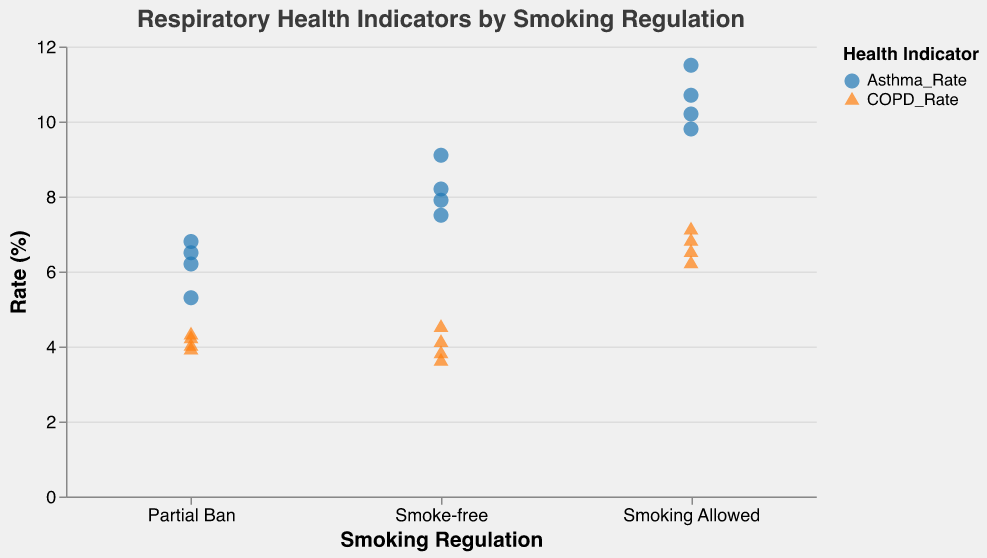What are the types of respiratory health indicators shown in the plot? The plot uses two shapes and colors to distinguish between different respiratory health indicators: a circle in blue represents Asthma Rate, and a triangle in orange represents COPD Rate.
Answer: Asthma Rate and COPD Rate What is the asthma rate in cities where smoking is allowed? Look for the blue circle points in the "Smoking Allowed" category on the x-axis and read their y-values. Beijing has 9.8%, Moscow has 10.2%, Cairo has 11.5%, and Jakarta has 10.7%.
Answer: 9.8%, 10.2%, 11.5%, and 10.7% How does the COPD rate in Rome compare to Paris? Compare the orange triangle points for Rome and Paris under the "Partial Ban" category. Rome shows 4.3%, and Paris shows 4.2%.
Answer: Rome: 4.3%, Paris: 4.2% Which city has the highest rate of asthma where smoking is allowed? Look for the blue circle points in the "Smoking Allowed" category and find the highest value on the y-axis which is 11.5% in Cairo.
Answer: Cairo What is the average COPD rate in smoke-free cities? Identify the orange triangle points in the "Smoke-free" category, then calculate the average of their y-values: (4.1 + 3.8 + 4.5 + 3.6) / 4 = 16 / 4
Answer: 4.0% In which category (Smoke-free, Partial Ban, Smoking Allowed) are asthma rates generally lower? Compare the distribution of blue circle points across the three categories. Smoke-free and Partial Ban categories have lower asthma rates compared to Smoking Allowed.
Answer: Smoke-free and Partial Ban What is the difference between the highest and lowest asthma rates in smoke-free cities? For the "Smoke-free" category, identify the highest and lowest blue circle values. The highest is 9.1% (Chicago), and the lowest is 7.5% (San Francisco). Calculate 9.1% - 7.5%.
Answer: 1.6% Which smoking regulation category shows the highest COPD rate overall? Look at the highest orange triangle points in each category; the "Smoking Allowed" category has the highest value at 7.1% (Cairo).
Answer: Smoking Allowed What is the relationship between smoking regulation and respiratory health indicators observed from the plot? Smoking Allowed cities tend to have higher values for both asthma and COPD rates (shown by higher positions of blue and orange points), while Smoke-free cities generally show lower rates.
Answer: Higher rates with less regulation Which city under partial ban has the highest asthma rate? Look for the blue circle points under the "Partial Ban" category and find the highest value, which is 6.8% in Paris.
Answer: Paris 